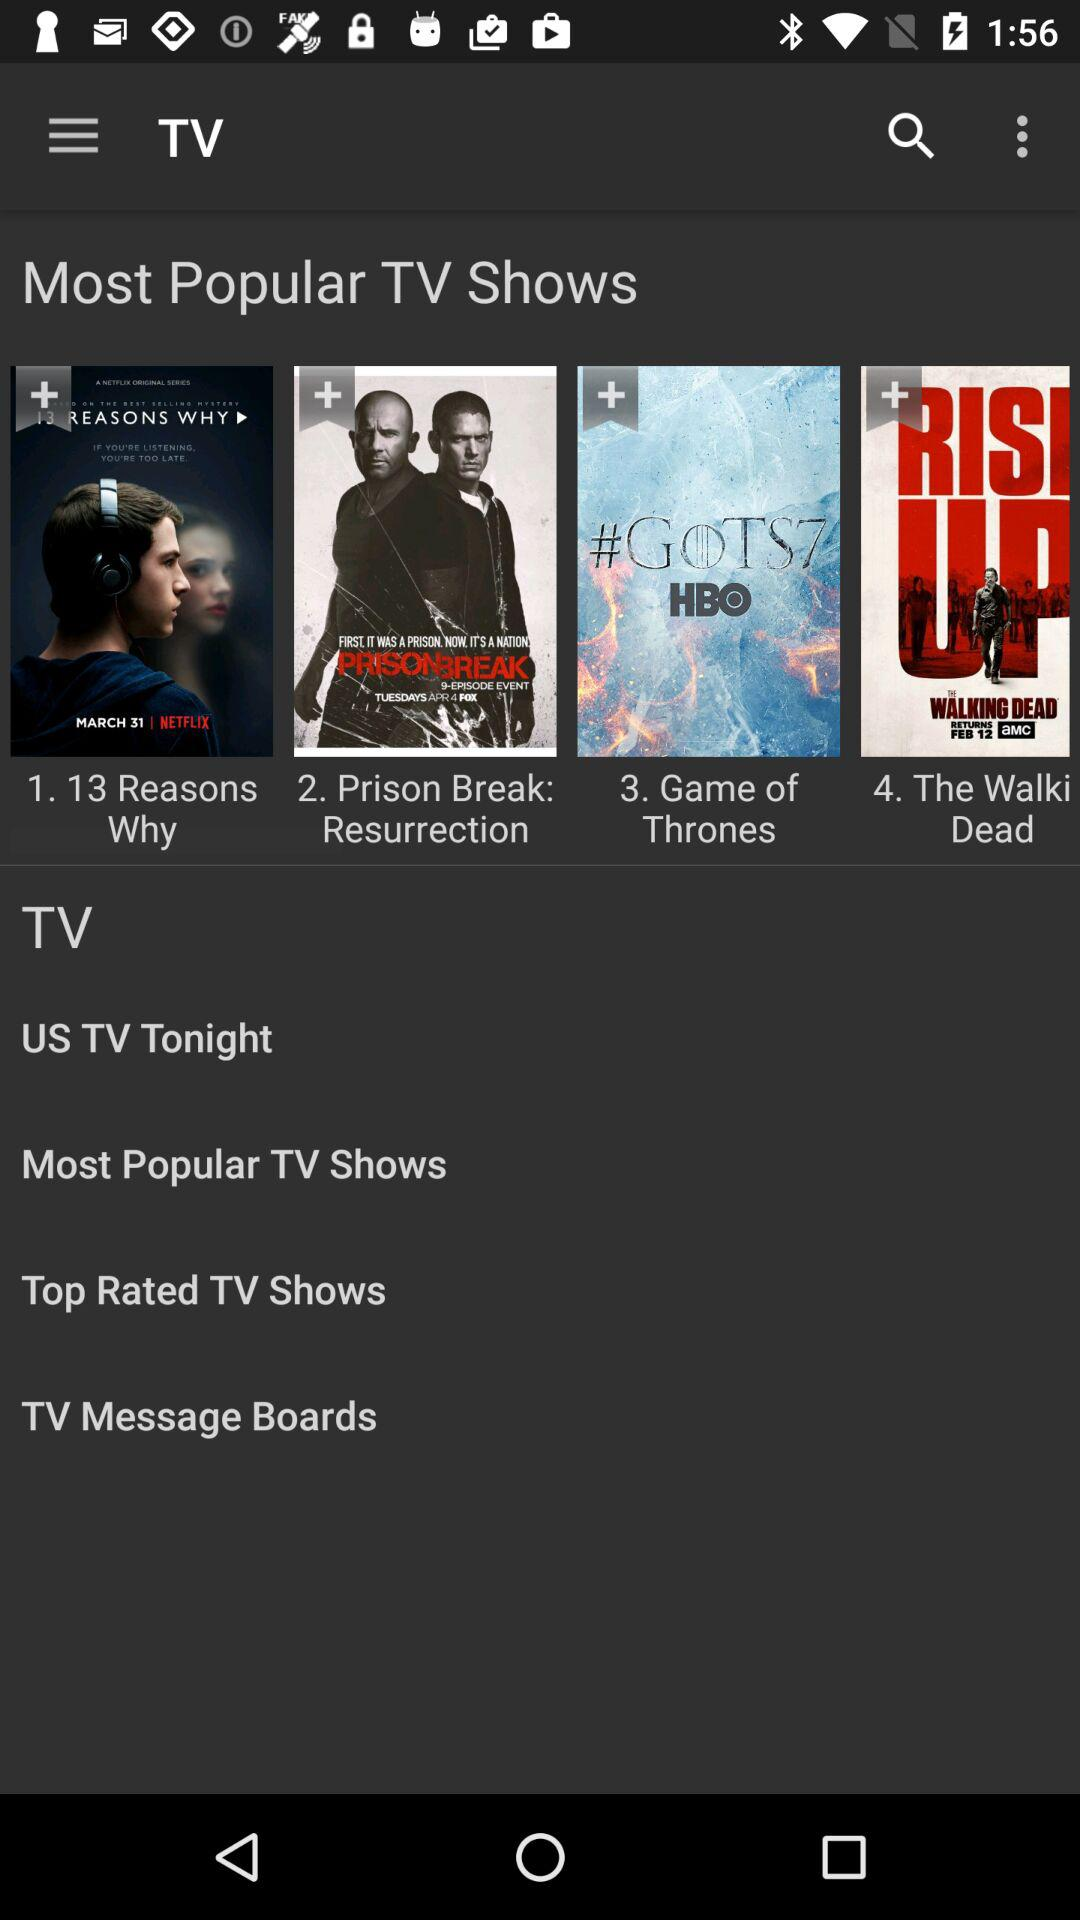What are the most popular TV shows? The most popular TV shows are "13 Reasons Why", "Prison Break: Resurrection", "Game of Thrones" and "The Walki Dead". 